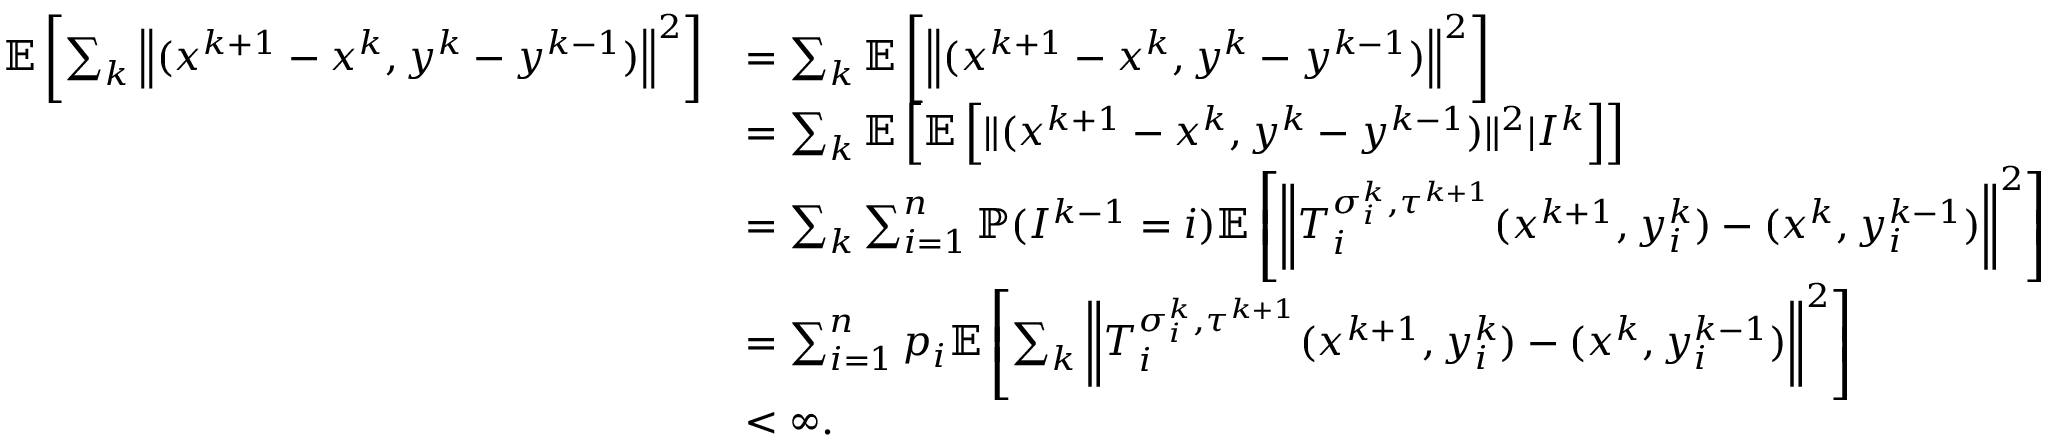<formula> <loc_0><loc_0><loc_500><loc_500>\begin{array} { r l } { \mathbb { E } \left [ \sum _ { k } \left \| ( x ^ { k + 1 } - x ^ { k } , y ^ { k } - y ^ { k - 1 } ) \right \| ^ { 2 } \right ] } & { = \sum _ { k } \mathbb { E } \left [ \left \| ( x ^ { k + 1 } - x ^ { k } , y ^ { k } - y ^ { k - 1 } ) \right \| ^ { 2 } \right ] } \\ & { = \sum _ { k } \mathbb { E } \left [ \mathbb { E } \left [ \| ( x ^ { k + 1 } - x ^ { k } , y ^ { k } - y ^ { k - 1 } ) \| ^ { 2 } | I ^ { k } \right ] \right ] } \\ & { = \sum _ { k } \sum _ { i = 1 } ^ { n } \mathbb { P } ( I ^ { k - 1 } = i ) \mathbb { E } \left [ \left \| T _ { i } ^ { \sigma _ { i } ^ { k } , \tau ^ { k + 1 } } ( x ^ { k + 1 } , y _ { i } ^ { k } ) - ( x ^ { k } , y _ { i } ^ { k - 1 } ) \right \| ^ { 2 } \right ] } \\ & { = \sum _ { i = 1 } ^ { n } p _ { i } \mathbb { E } \left [ \sum _ { k } \left \| T _ { i } ^ { \sigma _ { i } ^ { k } , \tau ^ { k + 1 } } ( x ^ { k + 1 } , y _ { i } ^ { k } ) - ( x ^ { k } , y _ { i } ^ { k - 1 } ) \right \| ^ { 2 } \right ] } \\ & { < \infty . } \end{array}</formula> 